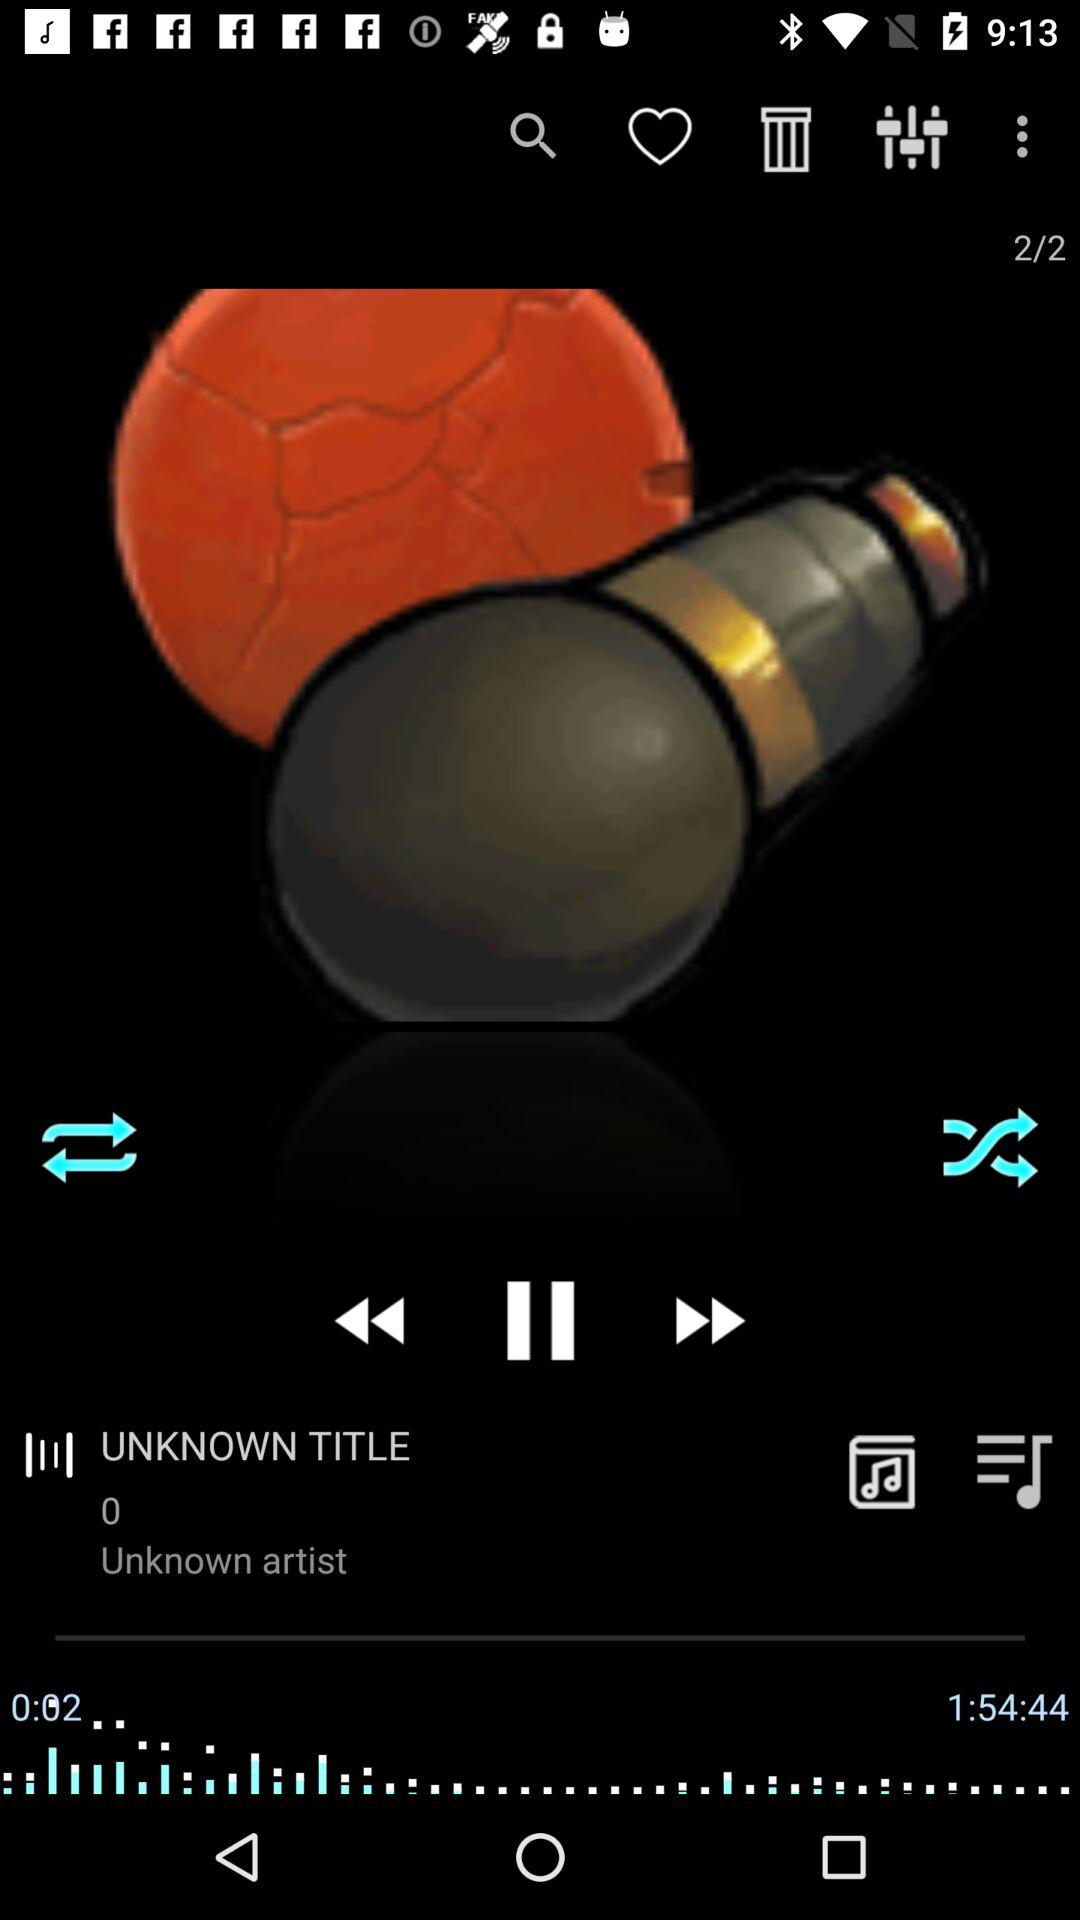When was the track uploaded?
When the provided information is insufficient, respond with <no answer>. <no answer> 